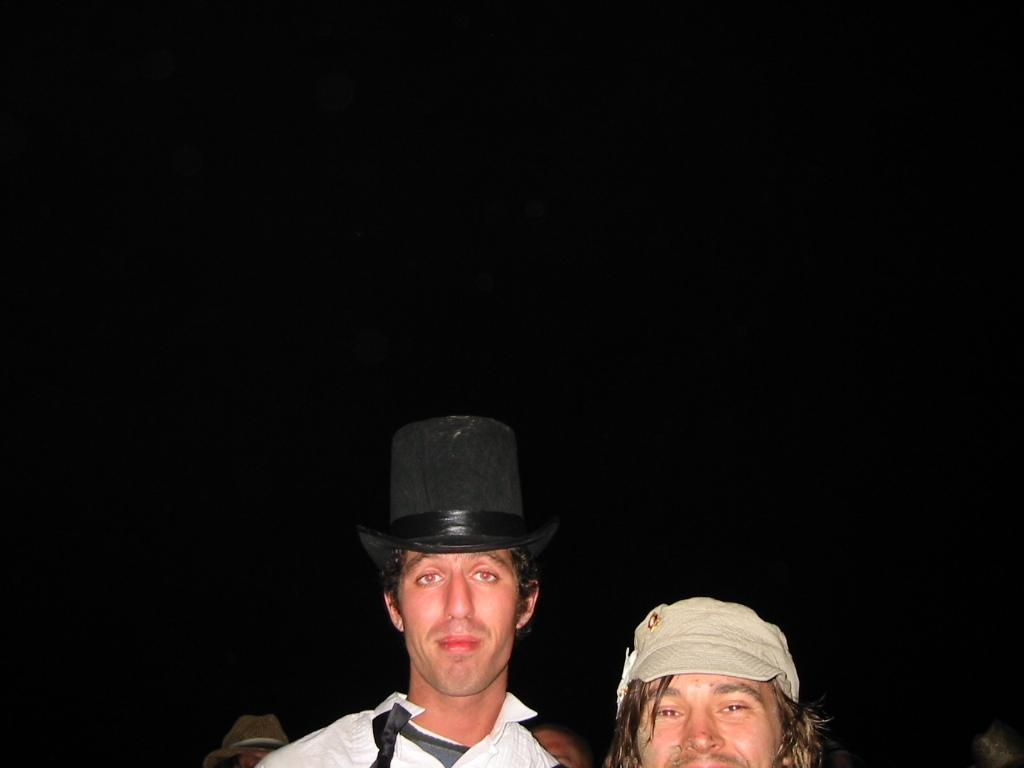What time of day is the image taken? The image is taken at night. What is the man wearing in the image? The man is wearing a white shirt and a black hat. How many people are in the image? There are two people in the image. What is the second man wearing in the image? The second man is wearing a cream cap. What type of knot is the man tying in the image? There is no knot-tying activity depicted in the image. Can you recite the verse that the man is singing in the image? There is no indication of singing or any verses in the image. 